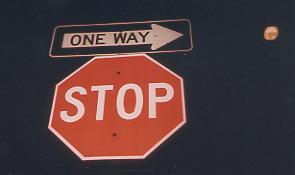What is above the stop sign?
Short answer required. One way sign. What is in the sky?
Give a very brief answer. Moon. Is there graffiti on the sign?
Answer briefly. No. Can you go more than one way here?
Answer briefly. No. Do these signs belong indoors?
Answer briefly. No. Are there any abbreviations on the sign?
Short answer required. No. How many stop signs are depicted?
Quick response, please. 1. What do the words ALWAYS mean here?
Concise answer only. Stop. Is it morning?
Be succinct. No. Is that a full moon in the upper right hand of the photo?
Write a very short answer. Yes. 